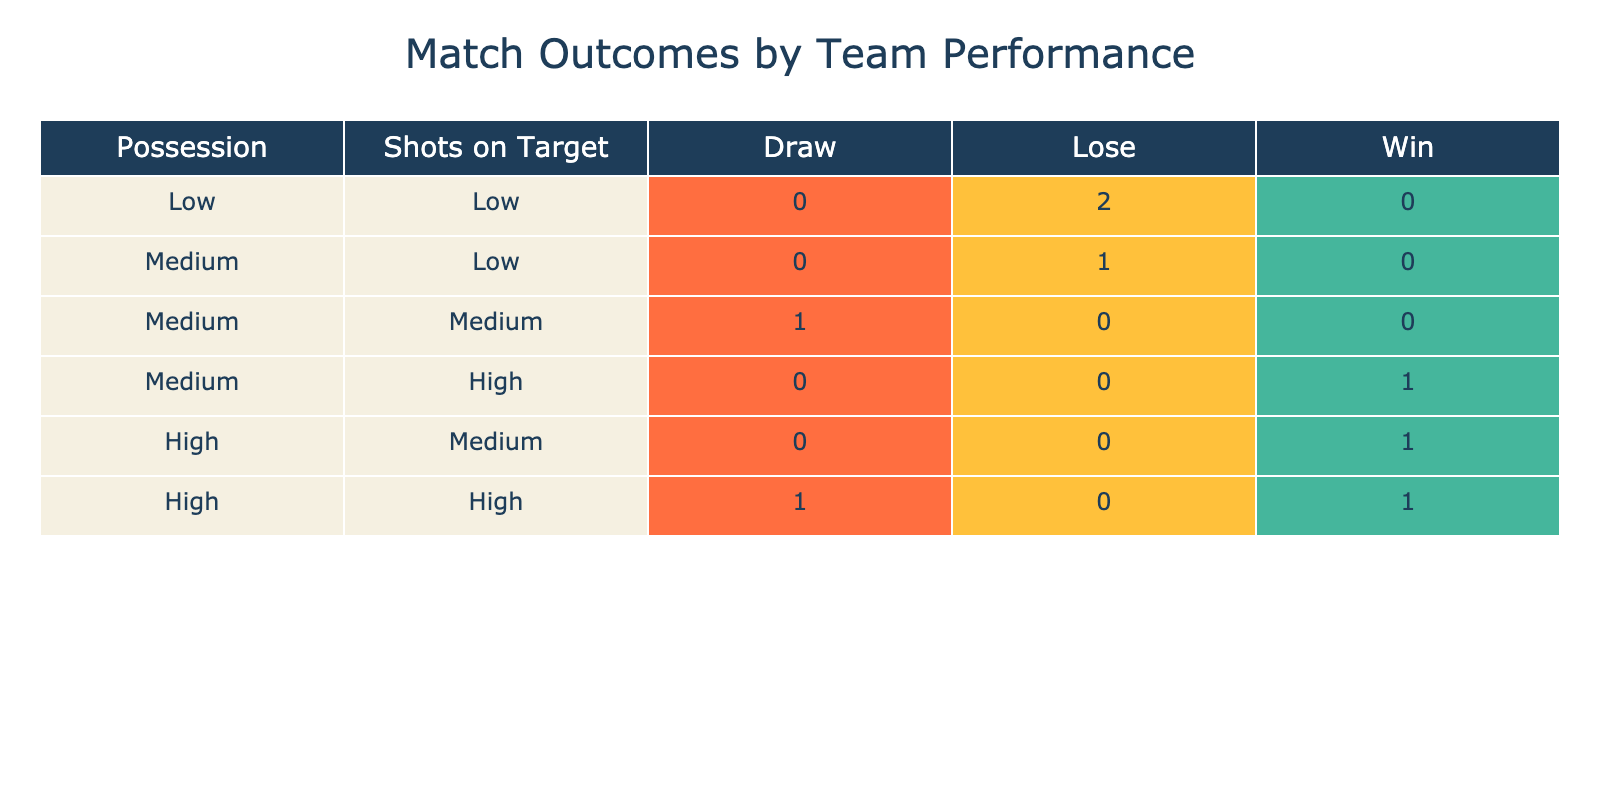What outcome did Lion City Sailors achieve with high possession and shots on target? Lion City Sailors had 70% possession and 8 shots on target, both of which fall into the 'High' category for possession and shots. According to the table, they achieved a 'Win' outcome.
Answer: Win What is the total number of matches that ended in a Draw? There are two teams listed with a Draw outcome: Tampines Rovers and Geylang International. By adding them together, we find that there is a total of 2 matches that ended in a Draw.
Answer: 2 Did any team achieve a Win with Low possession? The table shows that the teams with Low possession (40% or below) include Warriors FC and Balestier Khalsa. Both of these teams ended with a 'Lose' outcome, so there were no Wins under this category.
Answer: No What is the difference in the number of Wins between teams with High possession and Medium possession? There are 3 teams with High possession (Lion City Sailors, Hougang United, and Albirex Niigata) and they all achieved Wins. For Medium possession (55% to 65%), only Tampines Rovers achieved a Draw, and the other teams either Lost or Draw, giving them 3 Wins in total for High possession and 0 Wins for Medium possession. The difference is 3 - 0 = 3.
Answer: 3 How many teams had Medium shots on target and what was their outcome? The teams with Medium shots on target (between 4 and 6) are Albirex Niigata, Hougang United, and Tampines Rovers. Albirex Niigata won, Hougang United won, and Tampines Rovers drew, totaling 3 teams with Medium shots on target but with varying outcomes: 2 Wins and 1 Draw.
Answer: 3 teams, 2 Wins and 1 Draw What percentage of the teams ended in a Lose outcome? There are 8 teams in total and 3 teams (Balestier Khalsa, Young Lions, and Warriors FC) that ended in a Lose outcome. To find the percentage, we compute (3/8) * 100, which equals 37.5%.
Answer: 37.5% What is the average number of shots on target for teams that won? The teams that won are Albirex Niigata (7 shots), Hougang United (6 shots), and Lion City Sailors (8 shots). To find the average: (7 + 6 + 8) / 3 = 21 / 3 = 7.
Answer: 7 Is there any team that managed to secure a Win with less than 50% possession? Only two teams (Warriors FC and Young Lions) had less than 50% possession, and both ended up with a Lose outcome. No team managed a Win with under 50% possession.
Answer: No What outcome corresponds to a low possession and low shots on target? The only teams with low possession and low shots (Warriors FC and Balestier Khalsa) both achieved a 'Lose' outcome. Hence, teams with both low possession and low shots on target consistently ended with losses.
Answer: Lose 